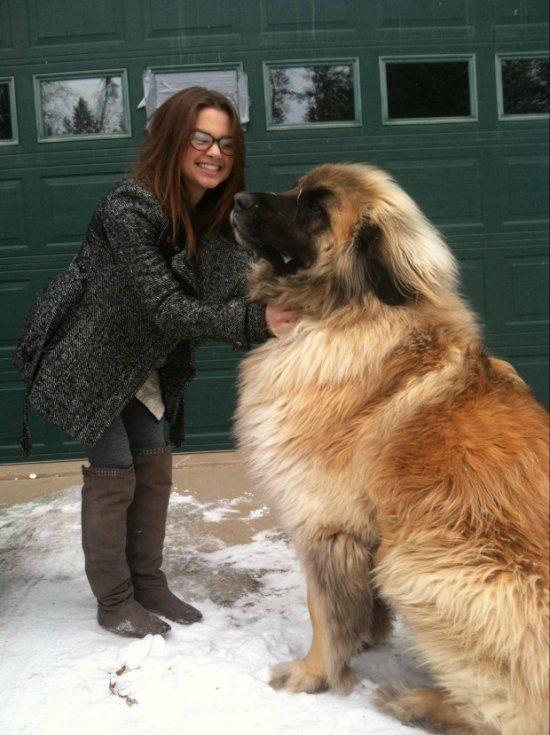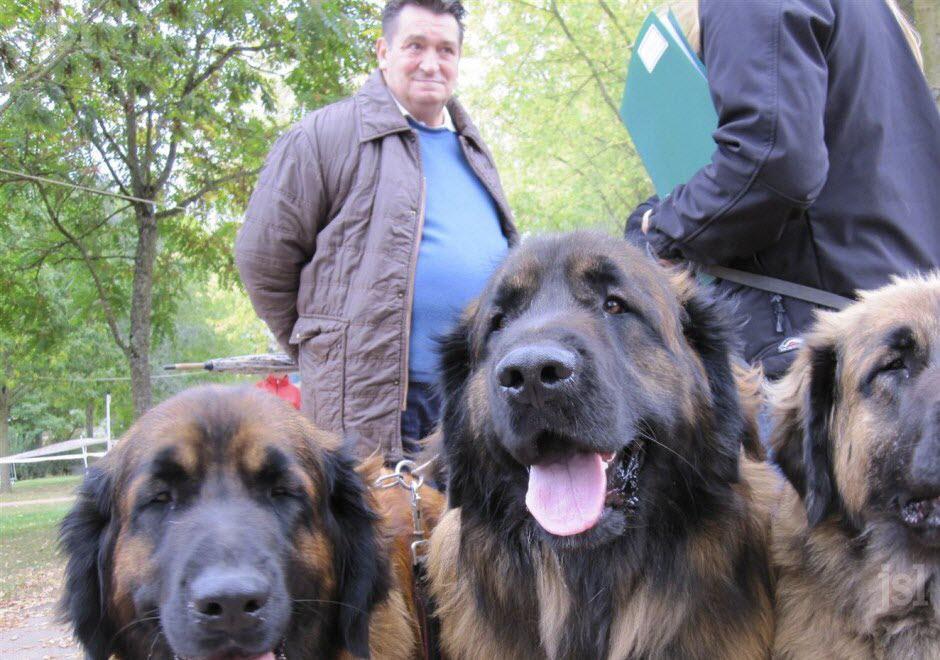The first image is the image on the left, the second image is the image on the right. Examine the images to the left and right. Is the description "There's at least one human petting a dog." accurate? Answer yes or no. Yes. The first image is the image on the left, the second image is the image on the right. Examine the images to the left and right. Is the description "There are three dogs in one of the images." accurate? Answer yes or no. Yes. 